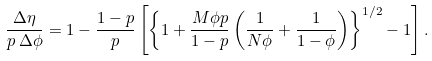Convert formula to latex. <formula><loc_0><loc_0><loc_500><loc_500>\frac { \Delta \eta } { p \, \Delta \phi } = 1 - \frac { 1 - p } { p } \left [ \left \{ 1 + \frac { M \phi p } { 1 - p } \left ( \frac { 1 } { N \phi } + \frac { 1 } { 1 - \phi } \right ) \right \} ^ { 1 / 2 } - 1 \right ] .</formula> 